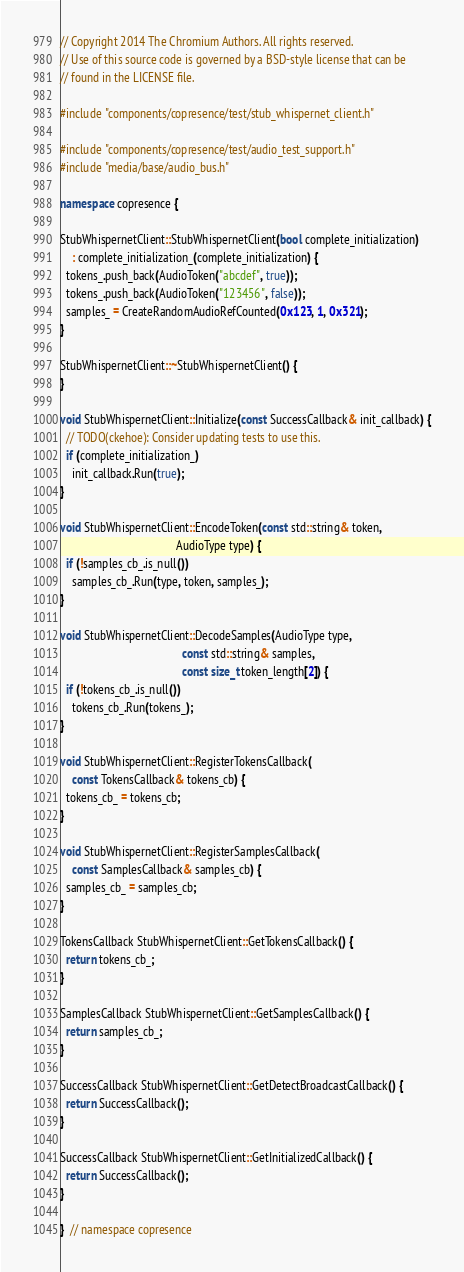Convert code to text. <code><loc_0><loc_0><loc_500><loc_500><_C++_>// Copyright 2014 The Chromium Authors. All rights reserved.
// Use of this source code is governed by a BSD-style license that can be
// found in the LICENSE file.

#include "components/copresence/test/stub_whispernet_client.h"

#include "components/copresence/test/audio_test_support.h"
#include "media/base/audio_bus.h"

namespace copresence {

StubWhispernetClient::StubWhispernetClient(bool complete_initialization)
    : complete_initialization_(complete_initialization) {
  tokens_.push_back(AudioToken("abcdef", true));
  tokens_.push_back(AudioToken("123456", false));
  samples_ = CreateRandomAudioRefCounted(0x123, 1, 0x321);
}

StubWhispernetClient::~StubWhispernetClient() {
}

void StubWhispernetClient::Initialize(const SuccessCallback& init_callback) {
  // TODO(ckehoe): Consider updating tests to use this.
  if (complete_initialization_)
    init_callback.Run(true);
}

void StubWhispernetClient::EncodeToken(const std::string& token,
                                       AudioType type) {
  if (!samples_cb_.is_null())
    samples_cb_.Run(type, token, samples_);
}

void StubWhispernetClient::DecodeSamples(AudioType type,
                                         const std::string& samples,
                                         const size_t token_length[2]) {
  if (!tokens_cb_.is_null())
    tokens_cb_.Run(tokens_);
}

void StubWhispernetClient::RegisterTokensCallback(
    const TokensCallback& tokens_cb) {
  tokens_cb_ = tokens_cb;
}

void StubWhispernetClient::RegisterSamplesCallback(
    const SamplesCallback& samples_cb) {
  samples_cb_ = samples_cb;
}

TokensCallback StubWhispernetClient::GetTokensCallback() {
  return tokens_cb_;
}

SamplesCallback StubWhispernetClient::GetSamplesCallback() {
  return samples_cb_;
}

SuccessCallback StubWhispernetClient::GetDetectBroadcastCallback() {
  return SuccessCallback();
}

SuccessCallback StubWhispernetClient::GetInitializedCallback() {
  return SuccessCallback();
}

}  // namespace copresence
</code> 